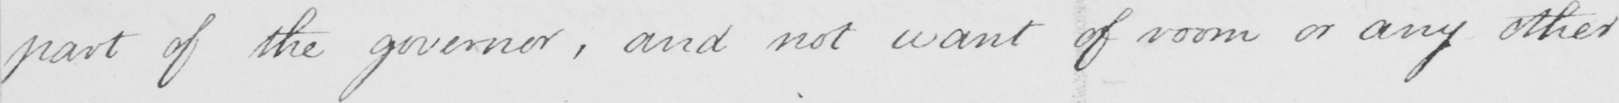Transcribe the text shown in this historical manuscript line. part of the governor , and not want of room or any other 